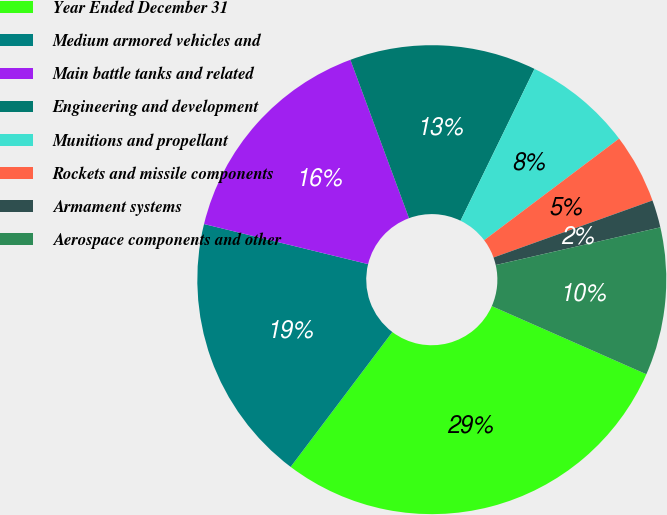Convert chart to OTSL. <chart><loc_0><loc_0><loc_500><loc_500><pie_chart><fcel>Year Ended December 31<fcel>Medium armored vehicles and<fcel>Main battle tanks and related<fcel>Engineering and development<fcel>Munitions and propellant<fcel>Rockets and missile components<fcel>Armament systems<fcel>Aerospace components and other<nl><fcel>28.67%<fcel>18.53%<fcel>15.54%<fcel>12.86%<fcel>7.51%<fcel>4.79%<fcel>1.9%<fcel>10.19%<nl></chart> 